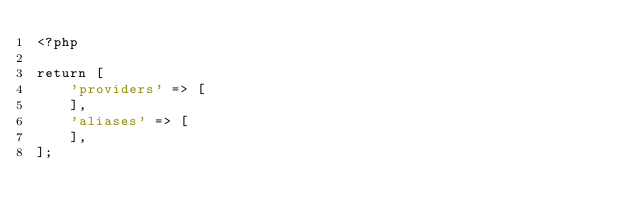<code> <loc_0><loc_0><loc_500><loc_500><_PHP_><?php

return [
    'providers' => [
    ],
    'aliases' => [
    ],
];
</code> 